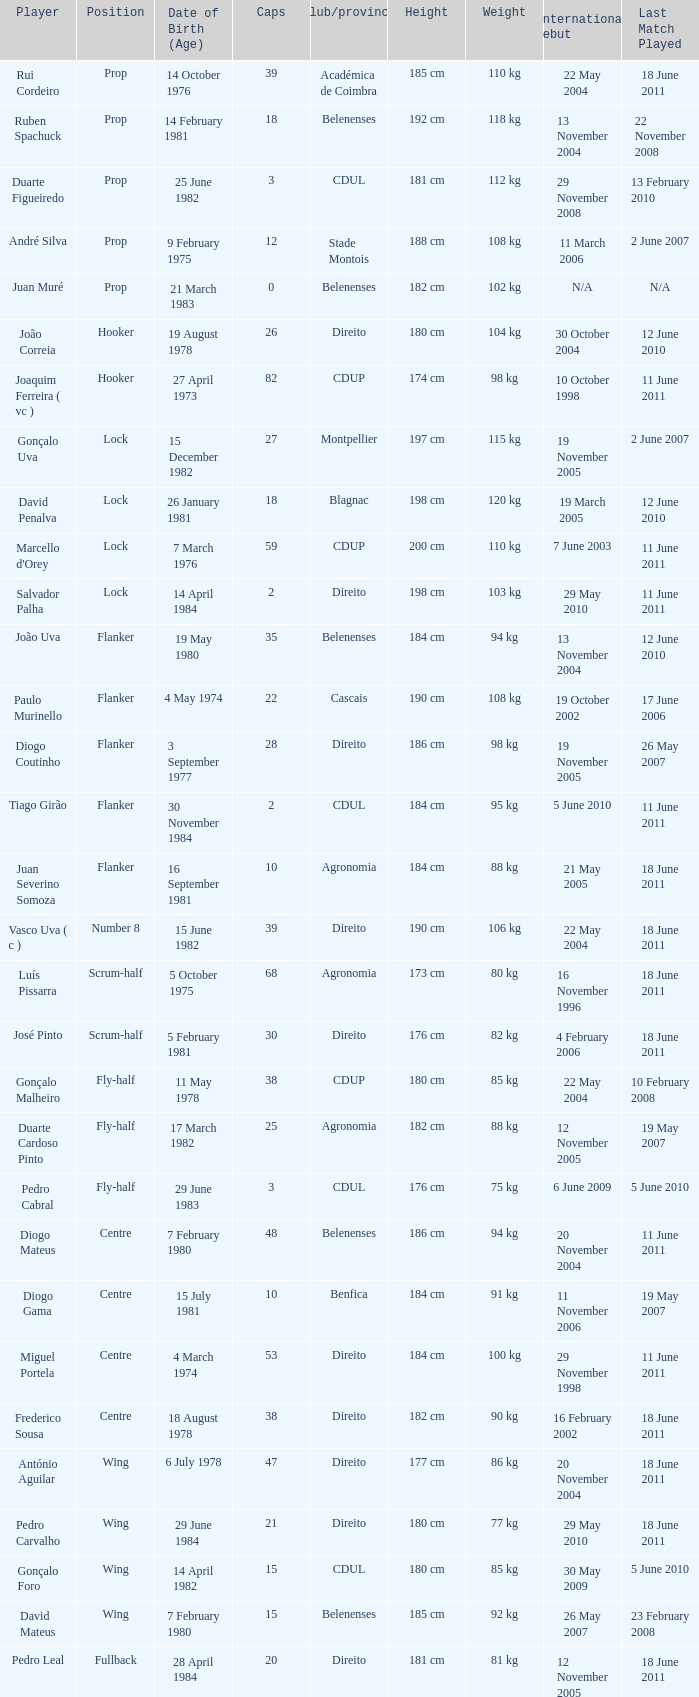How many caps have a Position of prop, and a Player of rui cordeiro? 1.0. 